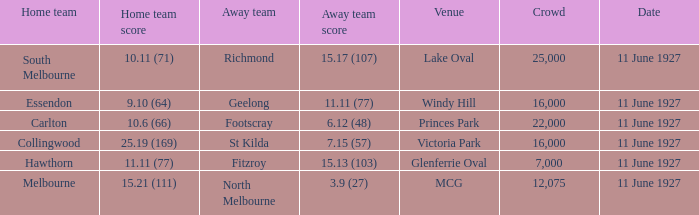What is the sum of all crowds present at the Glenferrie Oval venue? 7000.0. 